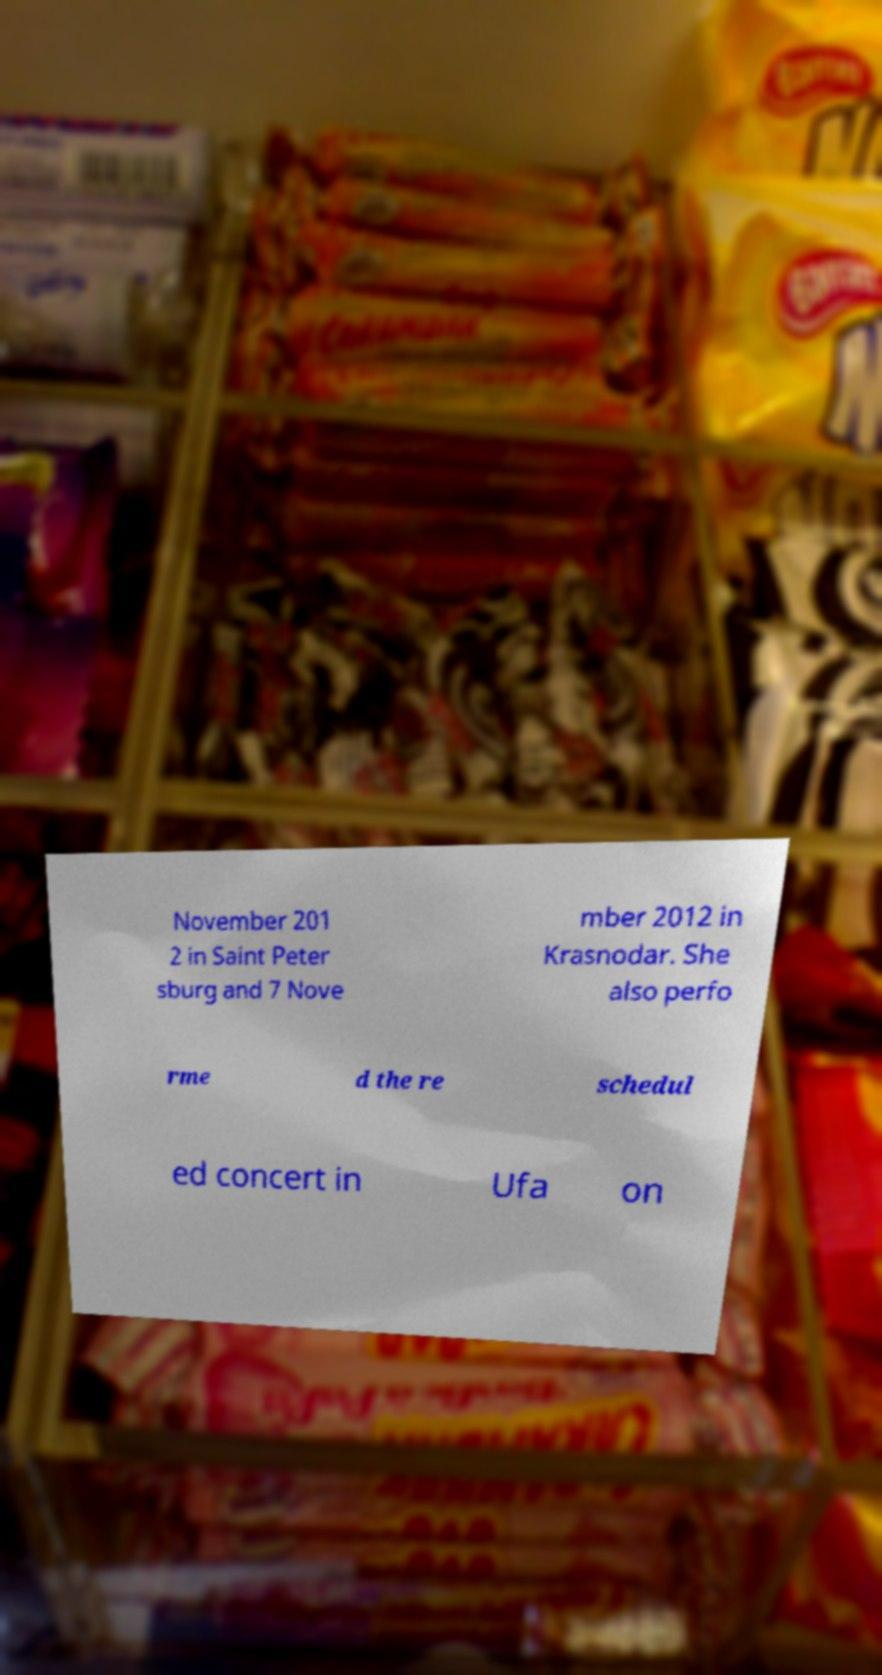Could you assist in decoding the text presented in this image and type it out clearly? November 201 2 in Saint Peter sburg and 7 Nove mber 2012 in Krasnodar. She also perfo rme d the re schedul ed concert in Ufa on 